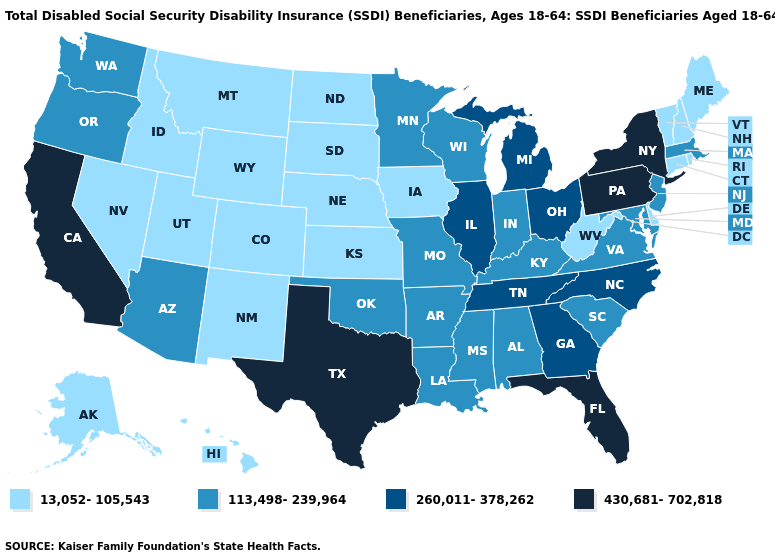Which states hav the highest value in the West?
Give a very brief answer. California. What is the value of Michigan?
Keep it brief. 260,011-378,262. What is the value of Hawaii?
Concise answer only. 13,052-105,543. Name the states that have a value in the range 13,052-105,543?
Keep it brief. Alaska, Colorado, Connecticut, Delaware, Hawaii, Idaho, Iowa, Kansas, Maine, Montana, Nebraska, Nevada, New Hampshire, New Mexico, North Dakota, Rhode Island, South Dakota, Utah, Vermont, West Virginia, Wyoming. Name the states that have a value in the range 13,052-105,543?
Quick response, please. Alaska, Colorado, Connecticut, Delaware, Hawaii, Idaho, Iowa, Kansas, Maine, Montana, Nebraska, Nevada, New Hampshire, New Mexico, North Dakota, Rhode Island, South Dakota, Utah, Vermont, West Virginia, Wyoming. Which states have the highest value in the USA?
Be succinct. California, Florida, New York, Pennsylvania, Texas. Which states have the highest value in the USA?
Answer briefly. California, Florida, New York, Pennsylvania, Texas. What is the value of Minnesota?
Be succinct. 113,498-239,964. Which states hav the highest value in the South?
Quick response, please. Florida, Texas. Among the states that border Vermont , does Massachusetts have the lowest value?
Quick response, please. No. What is the lowest value in states that border North Dakota?
Concise answer only. 13,052-105,543. Which states have the lowest value in the USA?
Concise answer only. Alaska, Colorado, Connecticut, Delaware, Hawaii, Idaho, Iowa, Kansas, Maine, Montana, Nebraska, Nevada, New Hampshire, New Mexico, North Dakota, Rhode Island, South Dakota, Utah, Vermont, West Virginia, Wyoming. What is the value of North Dakota?
Quick response, please. 13,052-105,543. Among the states that border Missouri , does Arkansas have the highest value?
Answer briefly. No. 